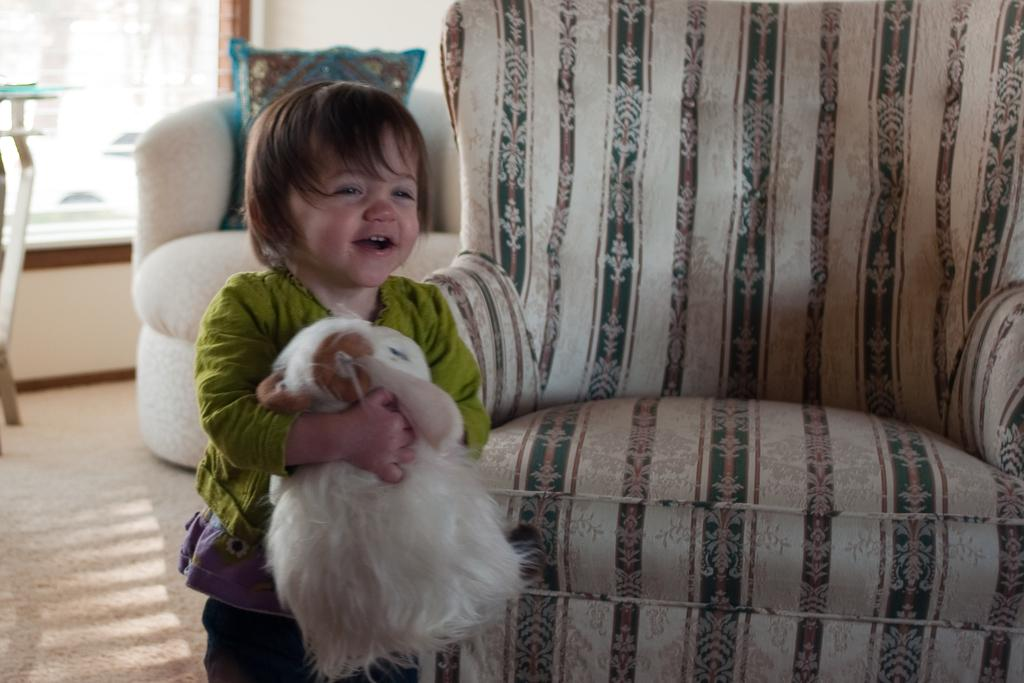What is the main subject of the image? There is a child in the image. What is the child doing in the image? The child is standing on the floor. What is the child holding in their hands? The child is holding a soft toy in their hands. What can be seen in the background of the image? There are couches and a mirror in the background of the image. What type of war is depicted in the image? There is no war depicted in the image; it features a child standing on the floor holding a soft toy. What kind of wren can be seen perched on the mirror in the image? There is no wren present in the image; it only shows a child, a soft toy, couches, and a mirror. 